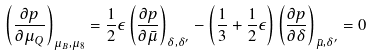<formula> <loc_0><loc_0><loc_500><loc_500>\left ( \frac { \partial p } { \partial \mu _ { Q } } \right ) _ { \mu _ { B } , \mu _ { 8 } } = \frac { 1 } { 2 } { \epsilon } \left ( \frac { \partial p } { \partial \bar { \mu } } \right ) _ { \delta , \delta ^ { \prime } } - \left ( \frac { 1 } { 3 } + \frac { 1 } { 2 } \epsilon \right ) \left ( \frac { \partial p } { \partial \delta } \right ) _ { \bar { \mu } , \delta ^ { \prime } } = 0</formula> 